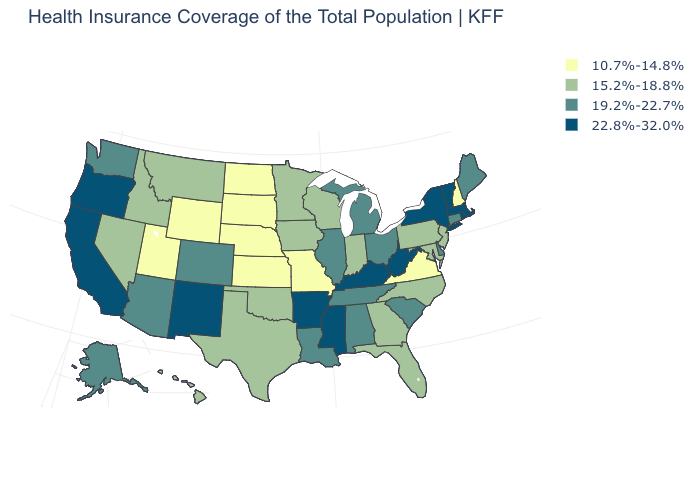What is the lowest value in the USA?
Write a very short answer. 10.7%-14.8%. Among the states that border Michigan , does Ohio have the highest value?
Quick response, please. Yes. Does the map have missing data?
Short answer required. No. What is the value of Oregon?
Give a very brief answer. 22.8%-32.0%. What is the highest value in the USA?
Quick response, please. 22.8%-32.0%. How many symbols are there in the legend?
Keep it brief. 4. Name the states that have a value in the range 15.2%-18.8%?
Concise answer only. Florida, Georgia, Hawaii, Idaho, Indiana, Iowa, Maryland, Minnesota, Montana, Nevada, New Jersey, North Carolina, Oklahoma, Pennsylvania, Texas, Wisconsin. Does the first symbol in the legend represent the smallest category?
Quick response, please. Yes. Does Michigan have the same value as Washington?
Concise answer only. Yes. What is the lowest value in the USA?
Concise answer only. 10.7%-14.8%. What is the highest value in the USA?
Give a very brief answer. 22.8%-32.0%. How many symbols are there in the legend?
Concise answer only. 4. Name the states that have a value in the range 22.8%-32.0%?
Give a very brief answer. Arkansas, California, Kentucky, Massachusetts, Mississippi, New Mexico, New York, Oregon, Rhode Island, Vermont, West Virginia. What is the highest value in the USA?
Short answer required. 22.8%-32.0%. Does Utah have the lowest value in the West?
Answer briefly. Yes. 